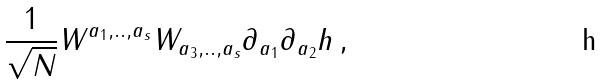<formula> <loc_0><loc_0><loc_500><loc_500>\frac { 1 } { \sqrt { N } } W ^ { a _ { 1 } , . . , a _ { s } } W _ { a _ { 3 } , . . , a _ { s } } \partial _ { a _ { 1 } } \partial _ { a _ { 2 } } h \, ,</formula> 